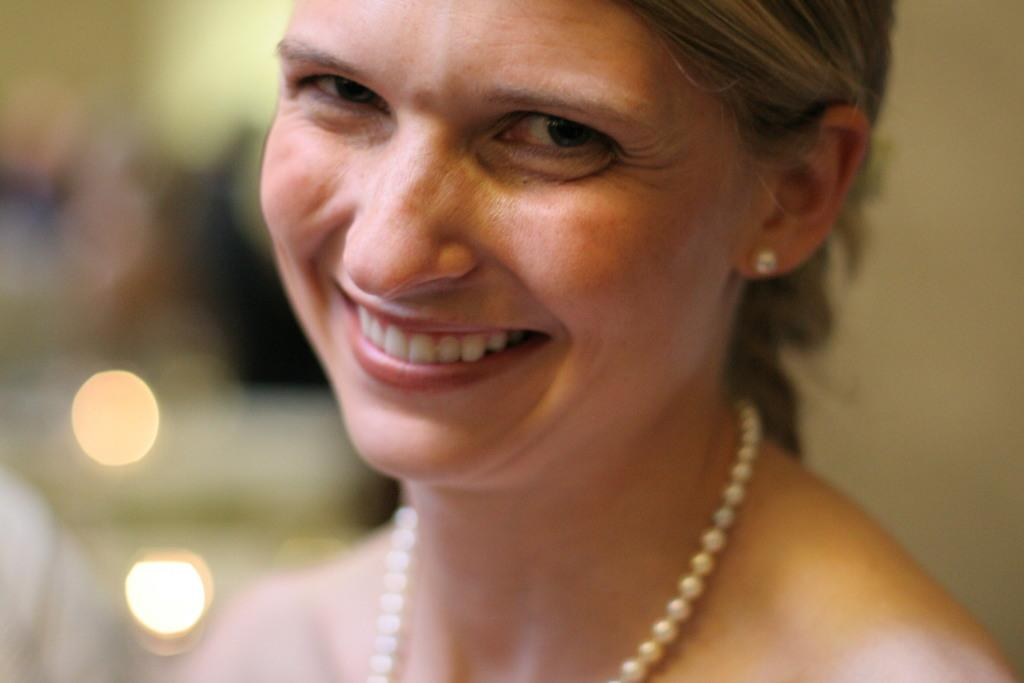What is the main subject of the image? There is a person in the image. Can you describe the background of the image? The background of the image is blurred. What can be observed about the person's appearance in the image? The person is wearing jewelry. What type of veil is covering the person's face in the image? There is no veil present in the image; the person's face is visible. What trip is the person planning to take, as seen in the image? There is no information about a trip in the image. 